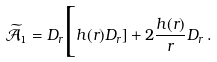Convert formula to latex. <formula><loc_0><loc_0><loc_500><loc_500>\mathcal { \widetilde { A } } _ { 1 } = D _ { r } \Big [ { h } ( r ) D _ { r } ] + 2 \frac { h ( r ) } { r } D _ { r } \, .</formula> 